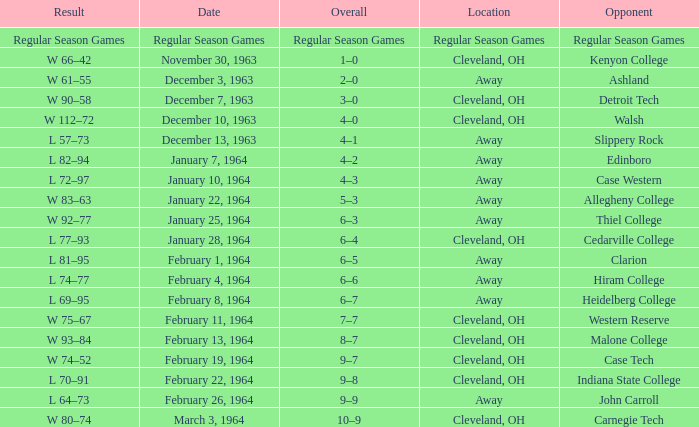What is the Location with a Date that is december 10, 1963? Cleveland, OH. 